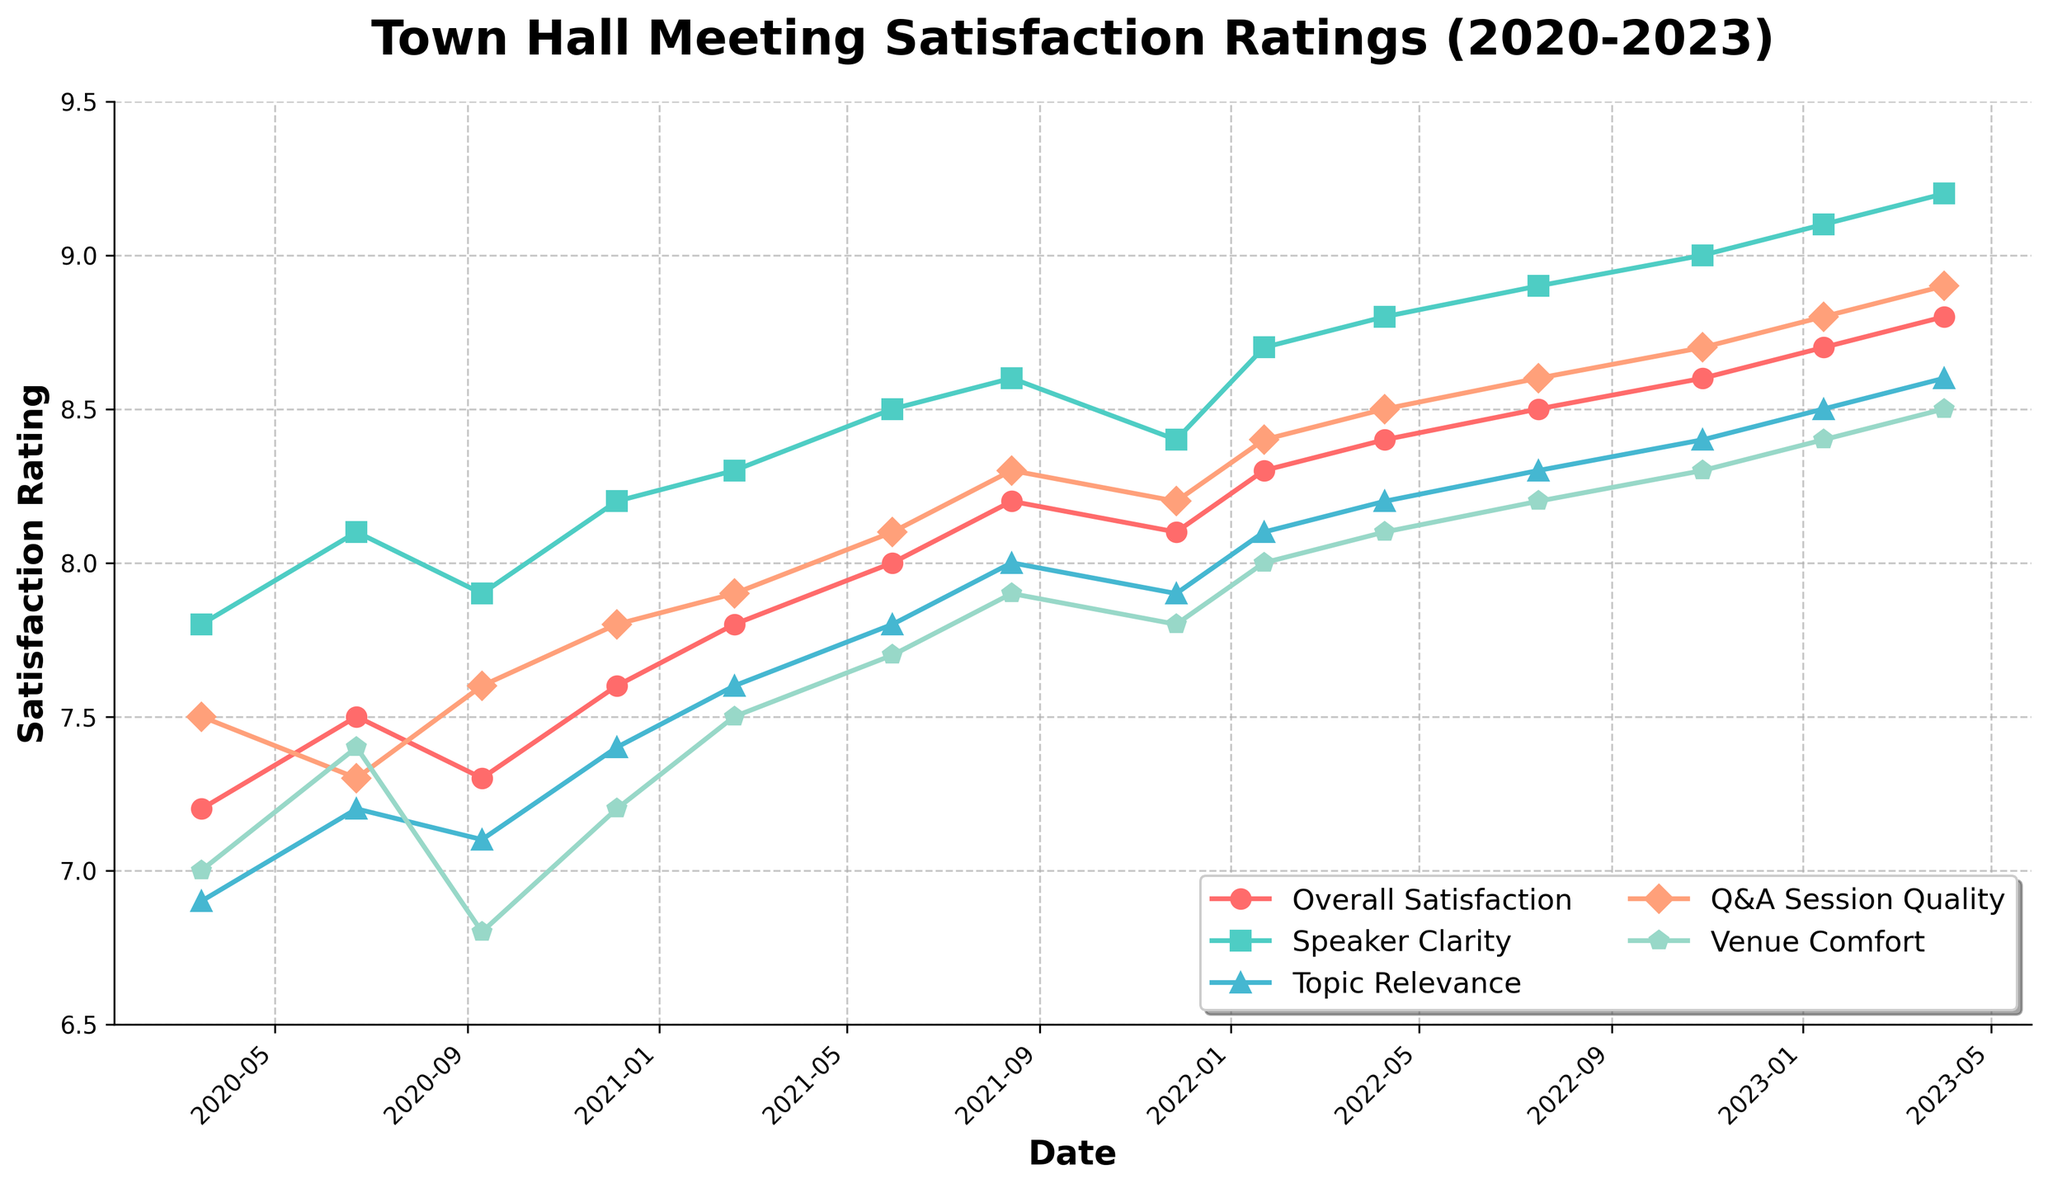what is the overall trend in the satisfaction ratings from 2020 to 2023? The overall trend in the satisfaction ratings from 2020 to 2023 shows a general increase across all metrics. Observing the plot, the lines representing each metric (Overall Satisfaction, Speaker Clarity, etc.) are trending upwards over the given period.
Answer: Increasing Which metric had the highest satisfaction rating in January 2023? To determine the highest satisfaction rating in January 2023, look at the points for January 2023 on the plot and identify the metric with the highest value. Speaker Clarity has the highest satisfaction rating at 9.1.
Answer: Speaker Clarity Compare the improvement in 'Overall Satisfaction' and 'Venue Comfort' between March 2020 and April 2023. Which one improved more? To compare, subtract the March 2020 ratings from the April 2023 ratings for both metrics. For 'Overall Satisfaction', 8.8 (April 2023) - 7.2 (March 2020) = 1.6. For 'Venue Comfort', 8.5 (April 2023) - 7.0 (March 2020) = 1.5. 'Overall Satisfaction' improved by 1.6, and 'Venue Comfort' improved by 1.5. So, 'Overall Satisfaction' improved more.
Answer: Overall Satisfaction What was the satisfaction rating for 'Q&A Session Quality' in May 2021, and how does it compare to the one in January 2022? The satisfaction rating for 'Q&A Session Quality' in May 2021 is 8.1, and for January 2022, it is 8.2. Comparing these two figures, we see an increase of 0.1.
Answer: 8.1, increased What is the average satisfaction rating for 'Topic Relevance' across all meetings in 2021? To calculate the average satisfaction rating for 'Topic Relevance' in 2021, add ratings for meetings in that year: 7.6 (Feb) + 7.8 (May) + 8.0 (Aug) + 7.9 (Nov) = 31.3. There are 4 data points, so the average is 31.3 / 4 = 7.975.
Answer: 7.975 Which month and year had the lowest satisfaction rating for 'Venue Comfort', and what was the rating? To find the lowest rating, observe the plot's line for 'Venue Comfort' and identify the lowest point. This occurs in September 2020 with a rating of 6.8.
Answer: September 2020, 6.8 Did 'Overall Satisfaction' and 'Speaker Clarity' follow a similar trend over the observed period? Analyzing the plot, both 'Overall Satisfaction' and 'Speaker Clarity' lines generally show a steadily increasing trend, indicating that they follow a similar upward trajectory over the period.
Answer: Yes What was the highest ever rating for 'Overall Satisfaction', and during which meeting did it occur? The highest rating for 'Overall Satisfaction' shown on the plot is 8.8, which occurred during the meeting in April 2023.
Answer: 8.8, April 2023 